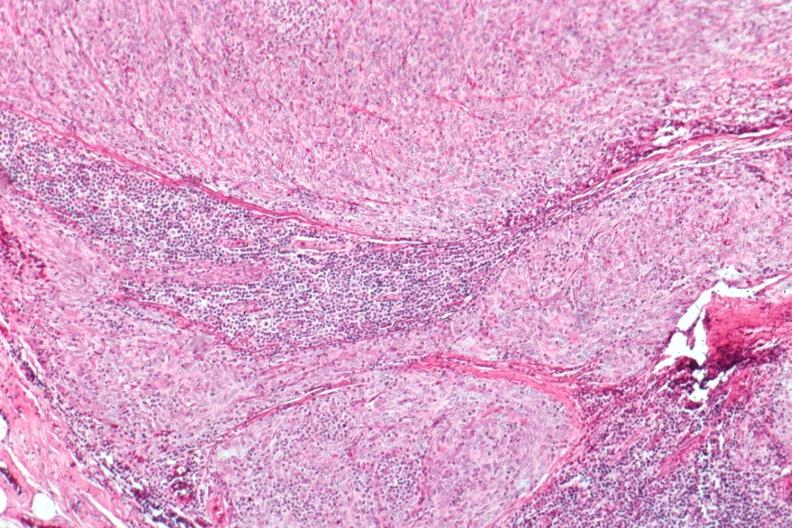what does this image show?
Answer the question using a single word or phrase. Epithelial predominant 